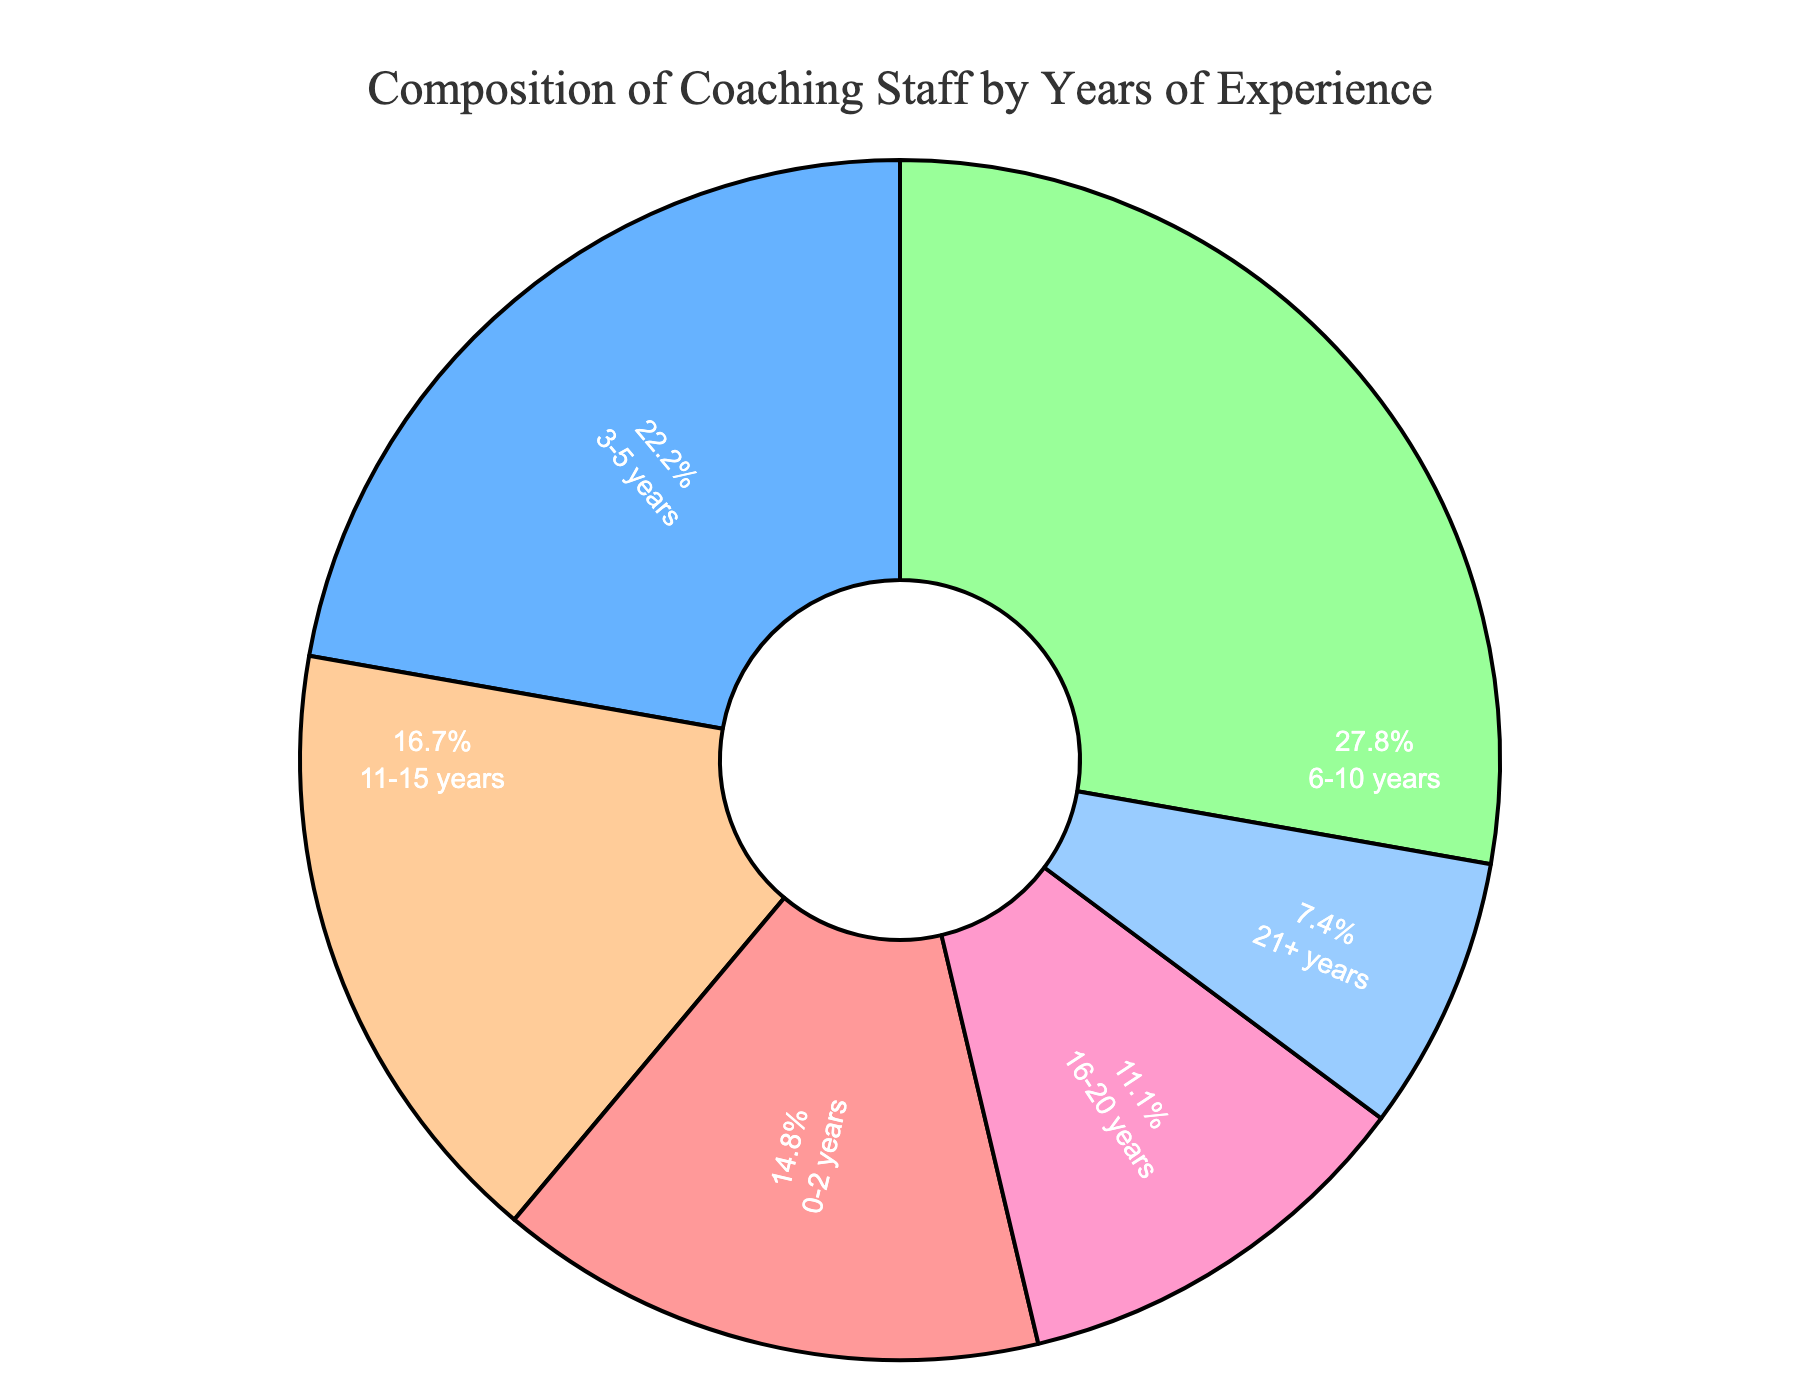what portion of the coaching staff has less than 6 years of experience? Sum the number of coaches with 0-2 years and 3-5 years of experience (8 + 12 = 20). Calculate the portion relative to the total number of coaches (8 + 12 + 15 + 9 + 6 + 4 = 54). The portion is 20/54, which is approximately 37%.
Answer: Approximately 37% Which experience bracket has the largest share of the coaching staff? From the figure, identify the experience bracket with the largest segment. 6-10 years experience has 15 coaches, the largest number among the brackets
Answer: 6-10 years What is the difference in the number of coaches between the 3-5 years and 11-15 years experience brackets? Subtract the number of coaches in the 11-15 years bracket from the number of coaches in the 3-5 years bracket (12 - 9 = 3).
Answer: 3 Which experience bracket is distinguished by the blue color? Identify the blue segment by observing the colors in the figure corresponding to different experience brackets. The blue color is assigned to the 3-5 years bracket.
Answer: 3-5 years If a new coach with 16-20 years of experience is added, how will the percentage change for the 16-20 years bracket? Add one to the number of coaches in the 16-20 years bracket (6 + 1 = 7). Recalculate the total number of coaches (54 + 1 = 55). Find the new percentage (7/55) * 100. This is approximately 12.7%.
Answer: Approximately 12.7% What percentage of coaches has 11 or more years of experience? Sum the number of coaches with 11-15 years, 16-20 years, and 21+ years of experience (9 + 6 + 4 = 19). Calculate the percentage relative to the total number of coaches (19/54) * 100, which is approximately 35.2%.
Answer: Approximately 35.2% How many more coaches are there in the 0-2 years bracket compared to the 21+ years bracket? Subtract the number of coaches in the 21+ years bracket from the number of coaches in the 0-2 years bracket (8 - 4 = 4).
Answer: 4 What is the smallest experience bracket by the number of coaches? From the figure, identify the smallest segment. The 21+ years experience bracket has the smallest number of coaches (4).
Answer: 21+ years Which two experience brackets have an equal percentage of 10 or more percent? Visually identify the segments representing 11-15 years and 6-10 years. Both brackets have significant portions of the pie chart, approximately around 10-20% each. Verify that both have distinct colors showcasing a comparably high percentage.
Answer: 11-15 years and 6-10 years What is the average number of coaches across all experience brackets? Sum the number of coaches in each bracket and divide by the number of brackets (54 / 6 = 9).
Answer: 9 